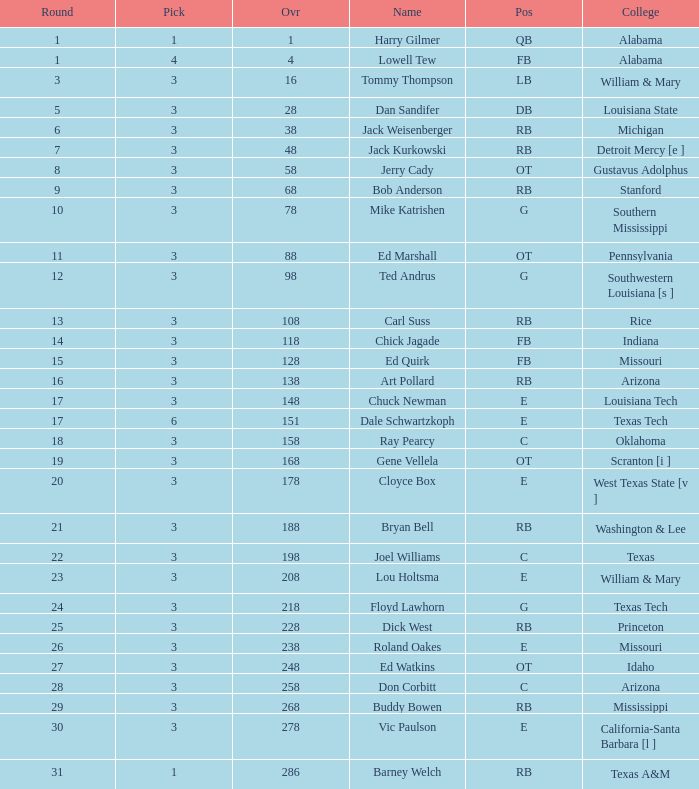Which pick has a Round smaller than 8, and an Overall smaller than 16, and a Name of harry gilmer? 1.0. 